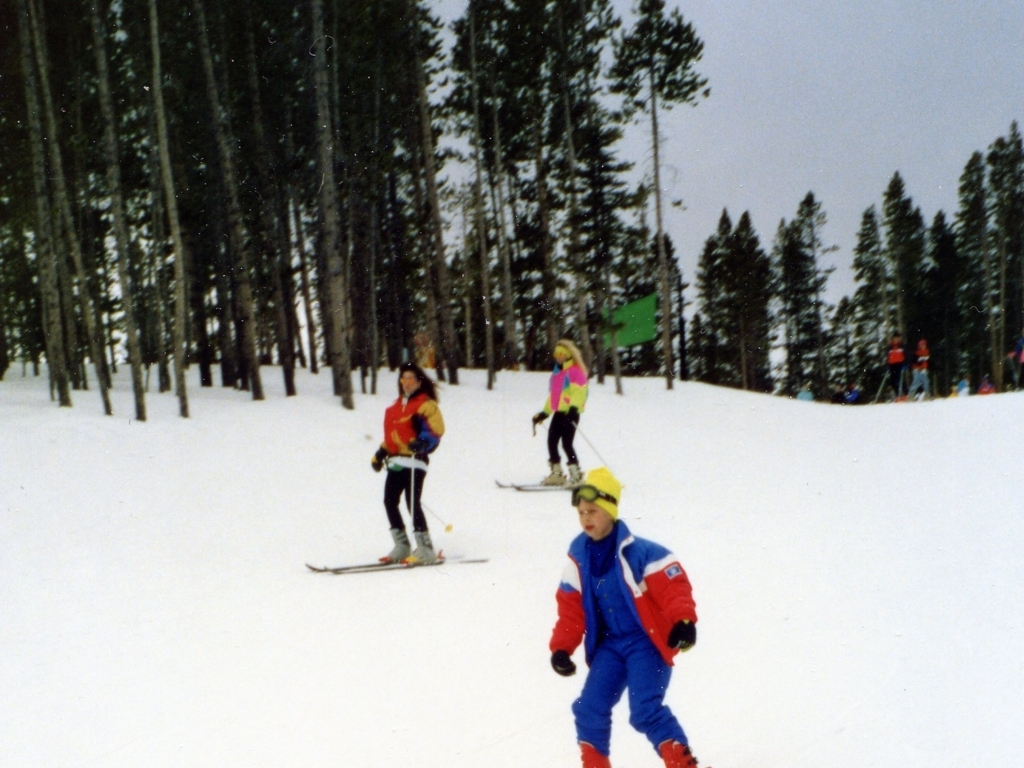Is there any distortion in the image?
A. No
B. Yes There appears to be no notable distortion in the image. It captures a group of skiers on a snowy slope with clarity, and the trees and people are well defined and proportional. 